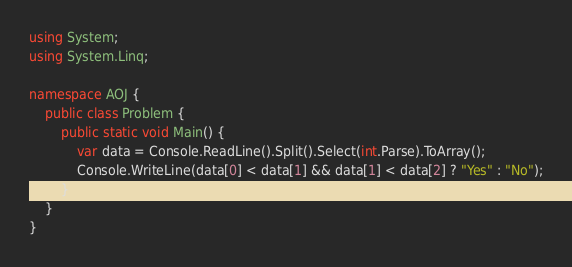<code> <loc_0><loc_0><loc_500><loc_500><_C#_>using System;
using System.Linq;

namespace AOJ {
    public class Problem {
        public static void Main() {
            var data = Console.ReadLine().Split().Select(int.Parse).ToArray();
            Console.WriteLine(data[0] < data[1] && data[1] < data[2] ? "Yes" : "No");
        }
    }
}
</code> 